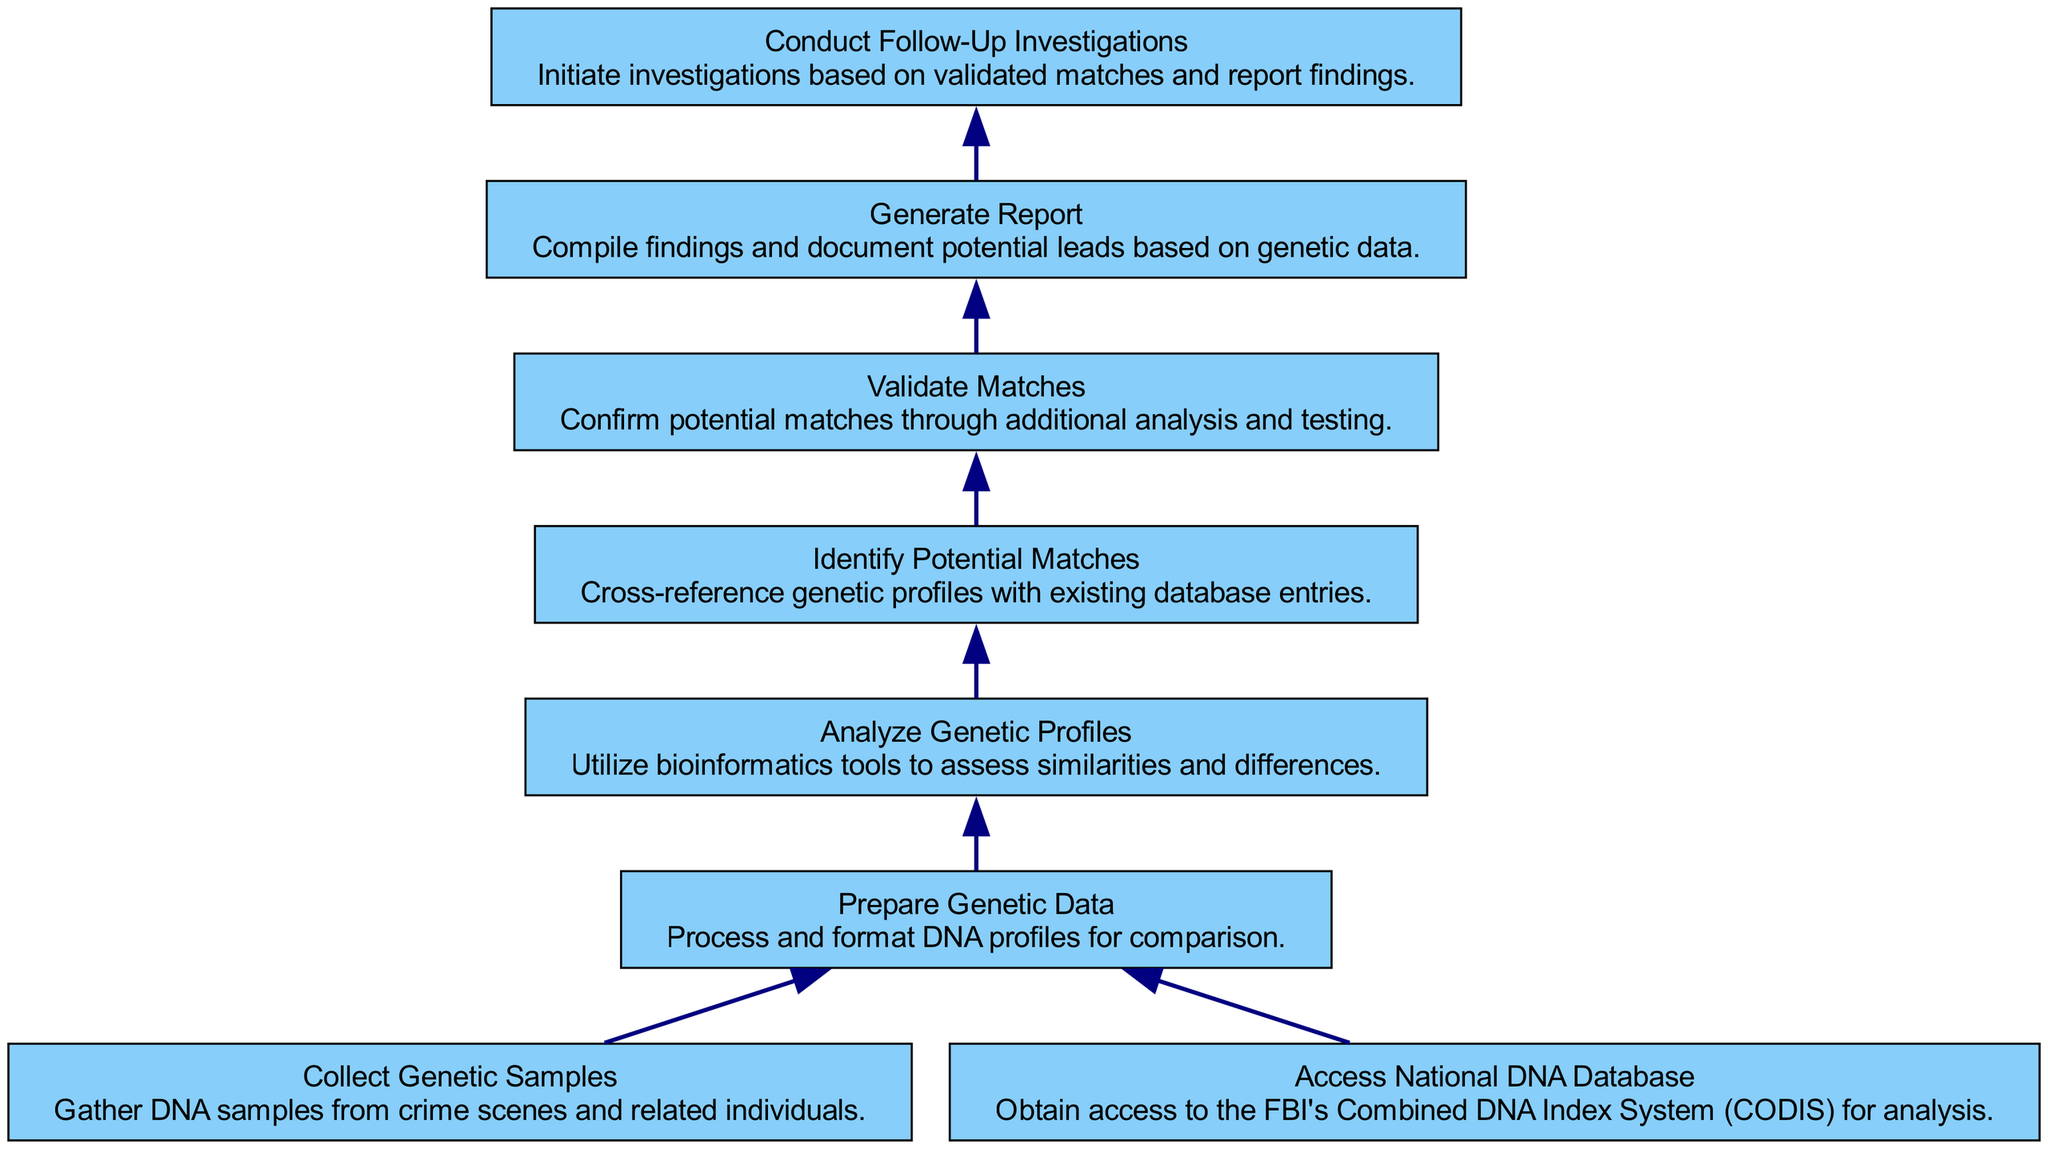What's the starting point of the flow? The starting point is "Collect Genetic Samples" as it is the first process in the diagram.
Answer: Collect Genetic Samples How many total elements are in the diagram? The diagram contains eight distinct elements as identified by their names and associated descriptions.
Answer: Eight Which element leads directly to "Analyze Genetic Profiles"? "Prepare Genetic Data" leads directly to "Analyze Genetic Profiles," indicating that data preparation is necessary for analysis.
Answer: Prepare Genetic Data What is the last element in the flow? The last element is "Conduct Follow-Up Investigations," which signifies the actions taken after reporting findings.
Answer: Conduct Follow-Up Investigations Which two elements are connected by the edge from "Validation"? The edge from "Validation" connects to "Generate Report," indicating that validation of matches leads to reporting findings.
Answer: Generate Report What action must be taken after "Identify Potential Matches"? After identifying potential matches, "Validate Matches" must be conducted to confirm those matches.
Answer: Validate Matches How many edges flow into the "Prepare Genetic Data" node? There are two edges flowing into the "Prepare Genetic Data" node, one from "Collect Genetic Samples" and another from "Access National DNA Database."
Answer: Two What is the relationship between "Analyze Genetic Profiles" and "Identify Potential Matches"? "Analyze Genetic Profiles" precedes "Identify Potential Matches," showing that analysis must occur before matching profiles.
Answer: Precedes What unique characteristic defines a Bottom Up Flow Chart in this context? The unique characteristic is that it organizes processes starting from the initial data collection and sequentially flows upward through various stages to the final outcome.
Answer: Sequential process 